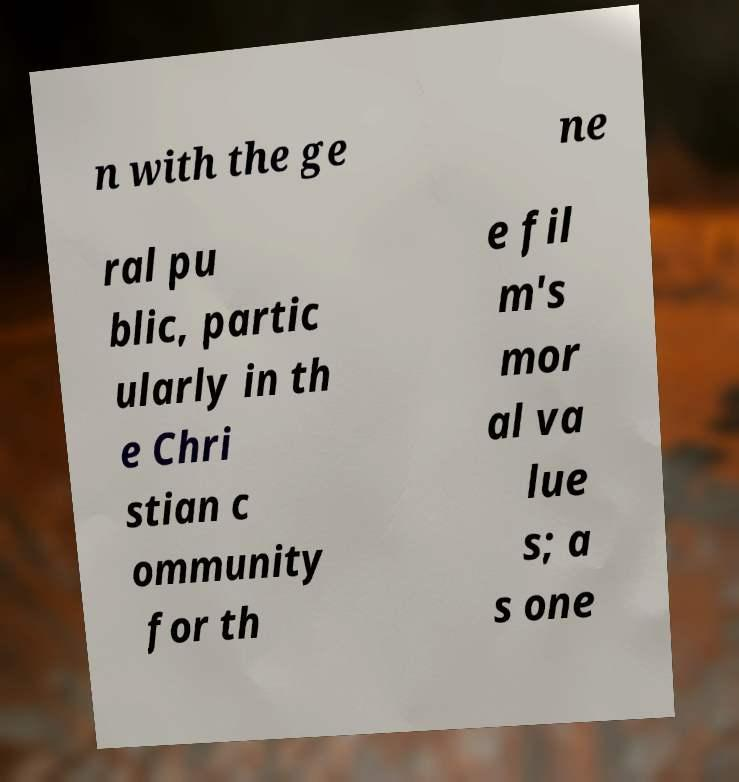Could you assist in decoding the text presented in this image and type it out clearly? n with the ge ne ral pu blic, partic ularly in th e Chri stian c ommunity for th e fil m's mor al va lue s; a s one 